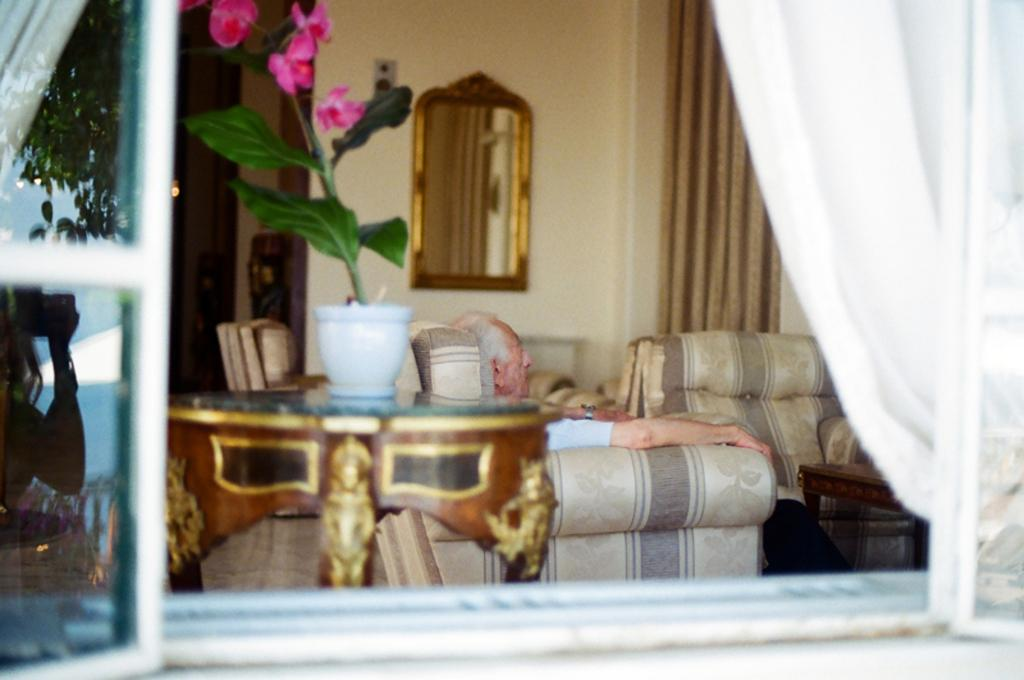What type of furniture is present in the image? There are sofas in the image. What kind of greenery can be seen in the image? There is a plant in the image. What is hanging on the wall in the image? There is a mirror on a wall in the image. What type of band is playing music in the image? There is no band present in the image. What shape is the plant in the image? The shape of the plant cannot be determined from the image alone, as it only shows the presence of a plant. 